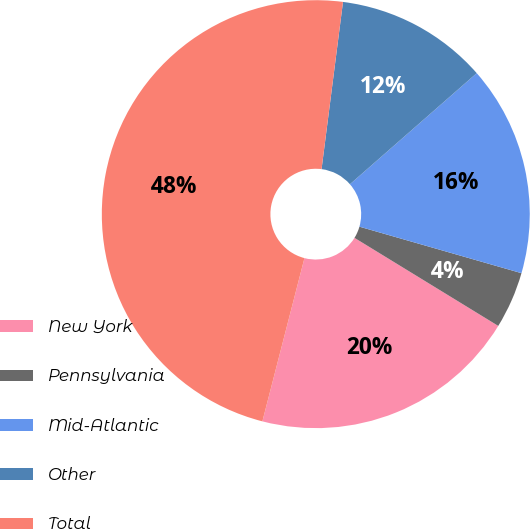Convert chart to OTSL. <chart><loc_0><loc_0><loc_500><loc_500><pie_chart><fcel>New York<fcel>Pennsylvania<fcel>Mid-Atlantic<fcel>Other<fcel>Total<nl><fcel>20.27%<fcel>4.3%<fcel>15.9%<fcel>11.52%<fcel>48.02%<nl></chart> 